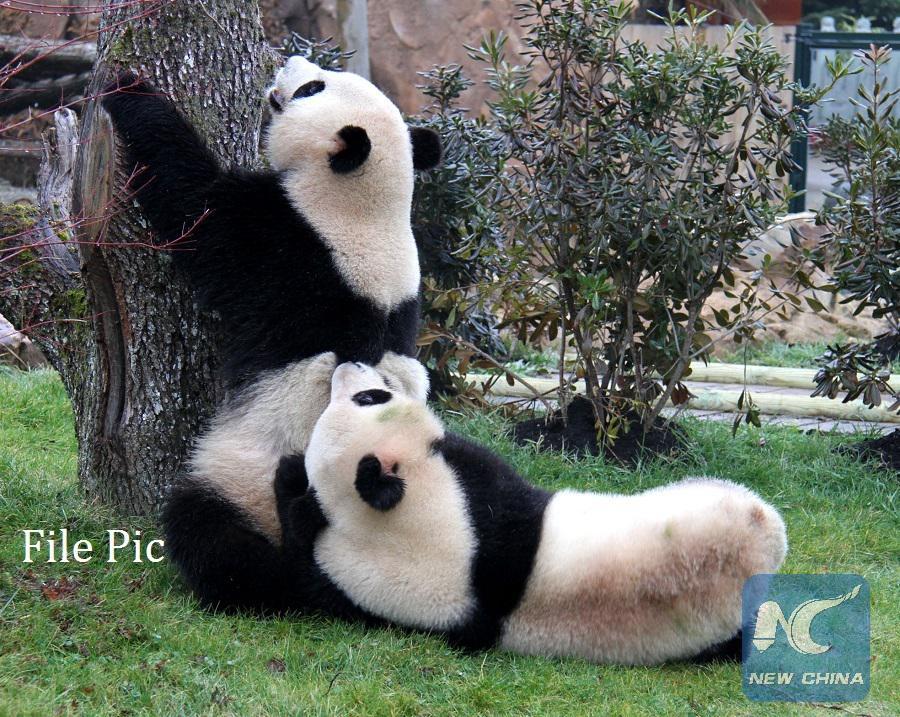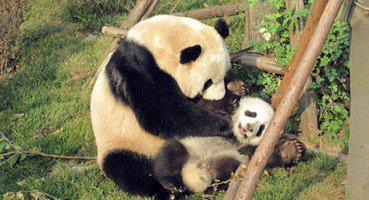The first image is the image on the left, the second image is the image on the right. Analyze the images presented: Is the assertion "One image shows a panda with its front paws on a large tree trunk, and the other image shows two pandas, one on top with its front paws on the other." valid? Answer yes or no. Yes. The first image is the image on the left, the second image is the image on the right. For the images displayed, is the sentence "there are pandas mating next to a rock which is next to a tree trunk with windowed fencing and green posts in the back ground" factually correct? Answer yes or no. No. 